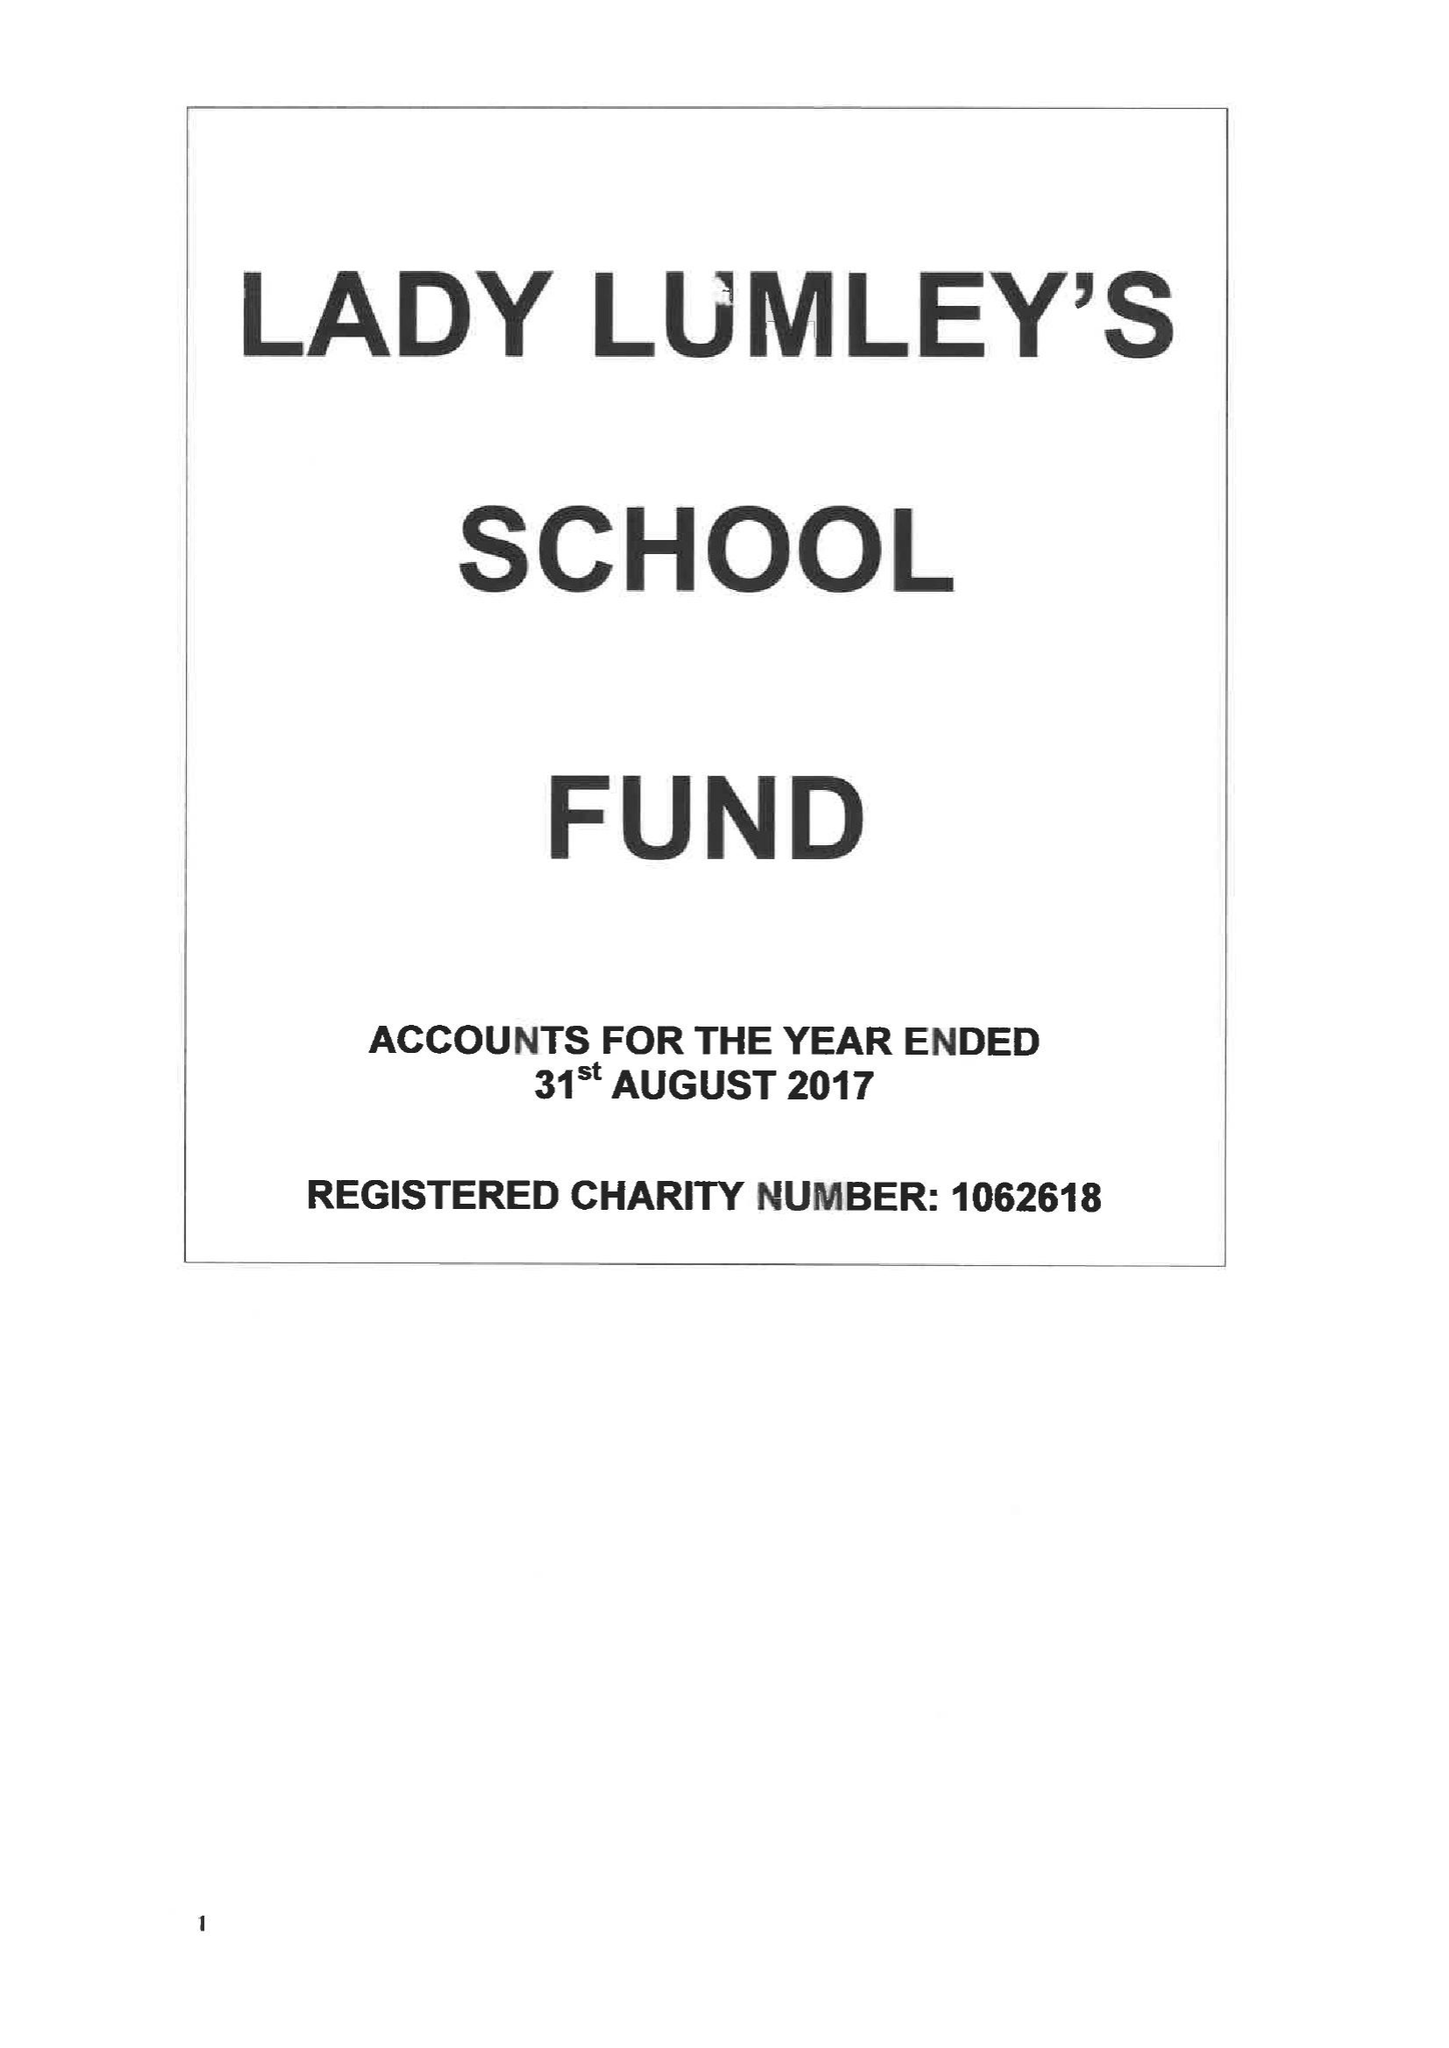What is the value for the spending_annually_in_british_pounds?
Answer the question using a single word or phrase. 52842.00 